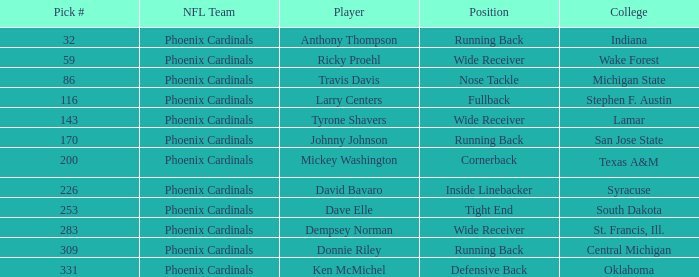Which college has a nose tackle position? Michigan State. 